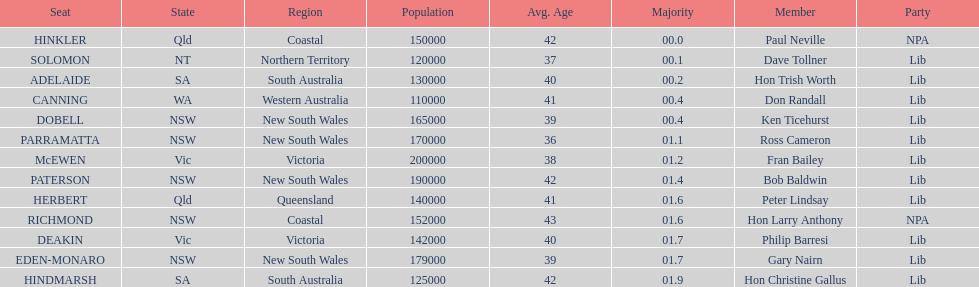What party had the most seats? Lib. 